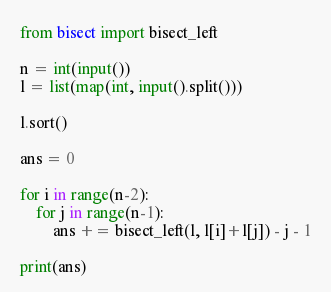Convert code to text. <code><loc_0><loc_0><loc_500><loc_500><_Python_>from bisect import bisect_left

n = int(input())
l = list(map(int, input().split()))

l.sort()

ans = 0

for i in range(n-2):
    for j in range(n-1):
        ans += bisect_left(l, l[i]+l[j]) - j - 1

print(ans)
</code> 